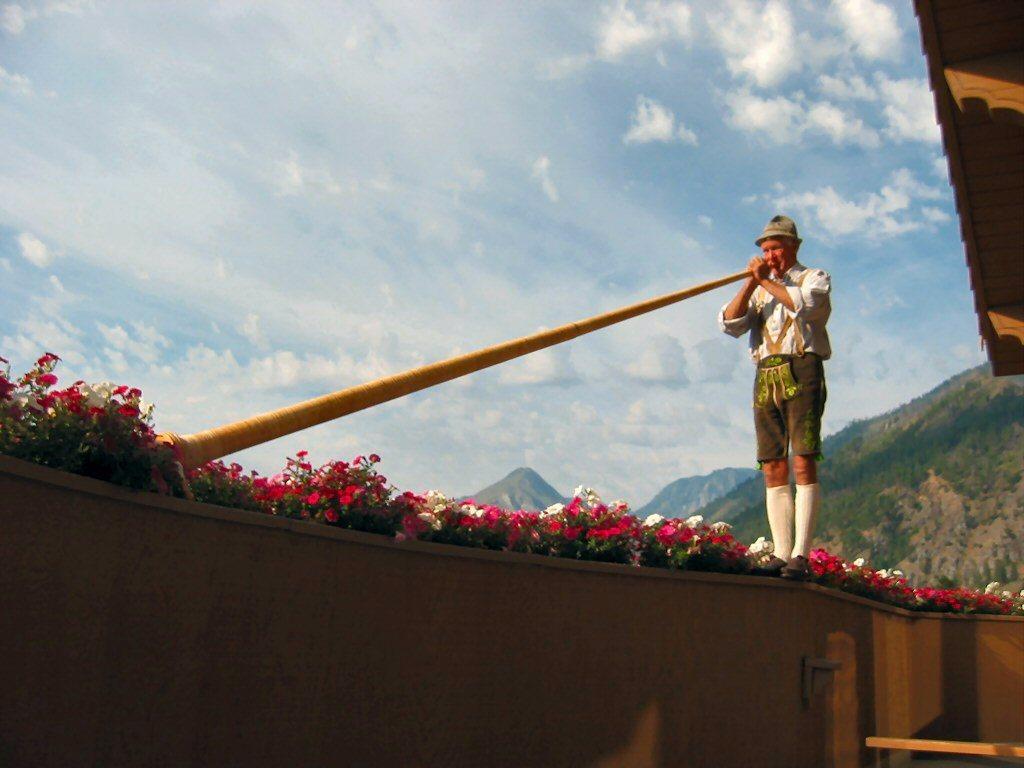Describe this image in one or two sentences. At the bottom of the image there is a wall with plants, pink and white flowers. There is a man with white shirt is standing and he is holding a big tube in his hands. At the top right corner of the image there is a roof. And in the background there are hills with trees and also there is a sky with clouds. 